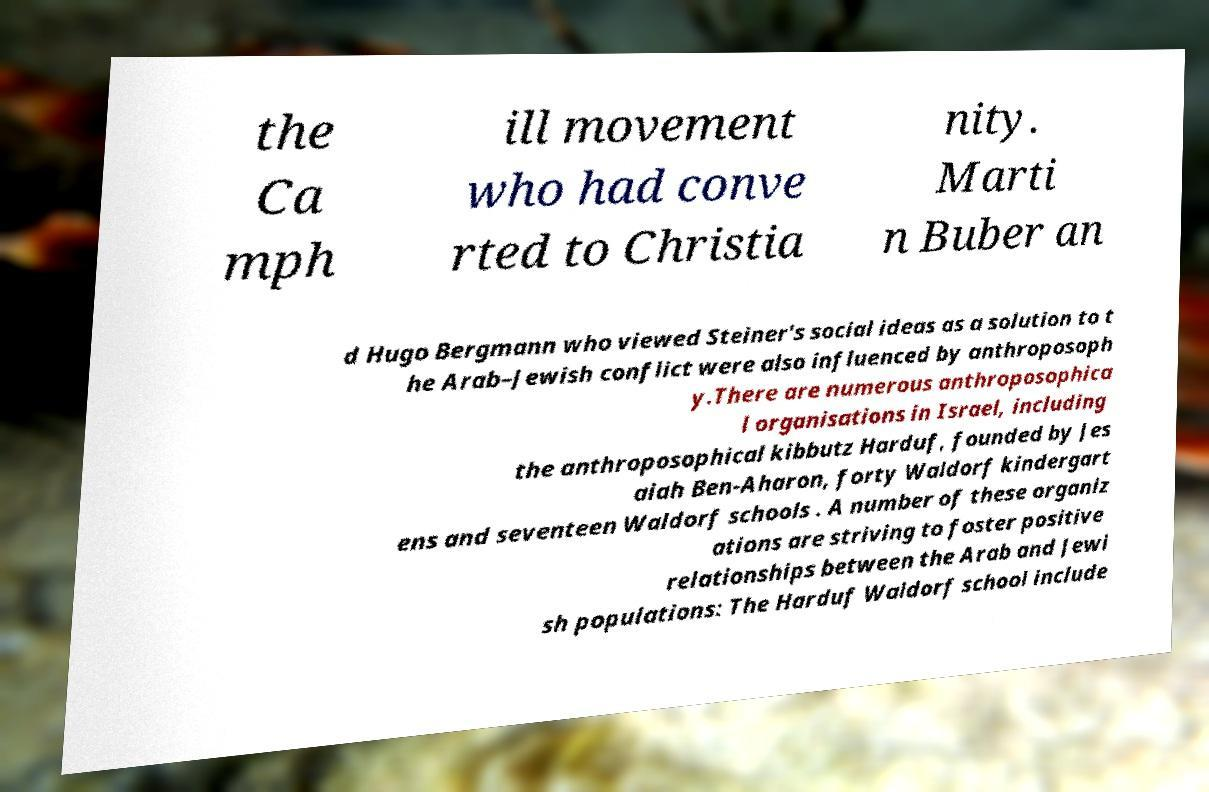What messages or text are displayed in this image? I need them in a readable, typed format. the Ca mph ill movement who had conve rted to Christia nity. Marti n Buber an d Hugo Bergmann who viewed Steiner's social ideas as a solution to t he Arab–Jewish conflict were also influenced by anthroposoph y.There are numerous anthroposophica l organisations in Israel, including the anthroposophical kibbutz Harduf, founded by Jes aiah Ben-Aharon, forty Waldorf kindergart ens and seventeen Waldorf schools . A number of these organiz ations are striving to foster positive relationships between the Arab and Jewi sh populations: The Harduf Waldorf school include 